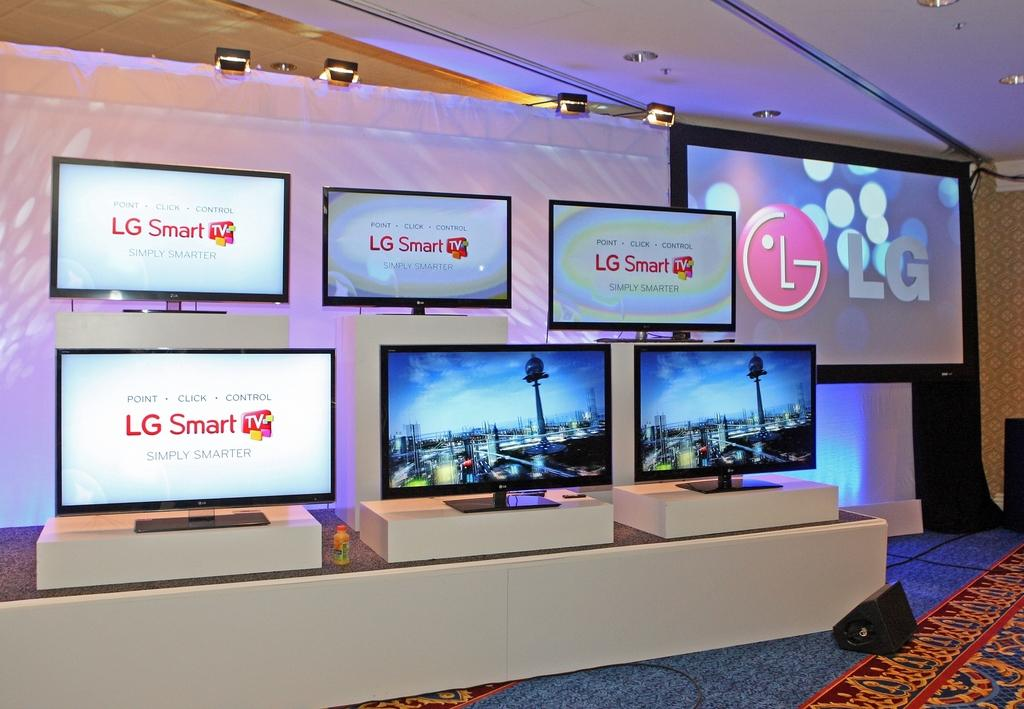<image>
Share a concise interpretation of the image provided. Several monitors that say LG Smart are in a display in front of a white wall. 